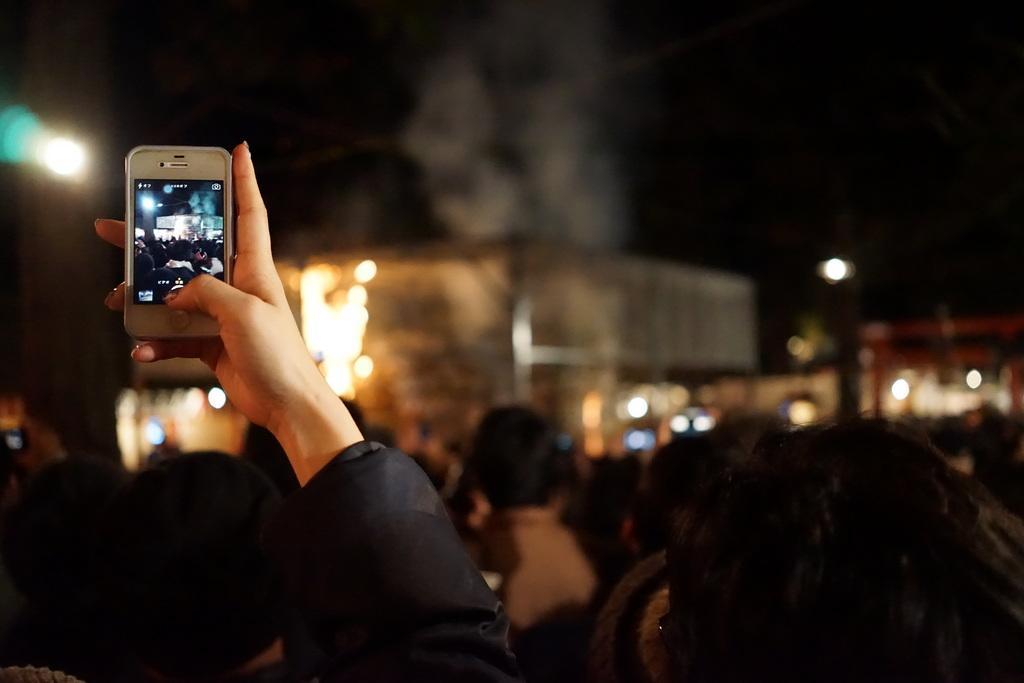In one or two sentences, can you explain what this image depicts? The image is taken in the crowd. We can see a person's hand holding a camera and capturing a image. In the background there are buildings and lights. 